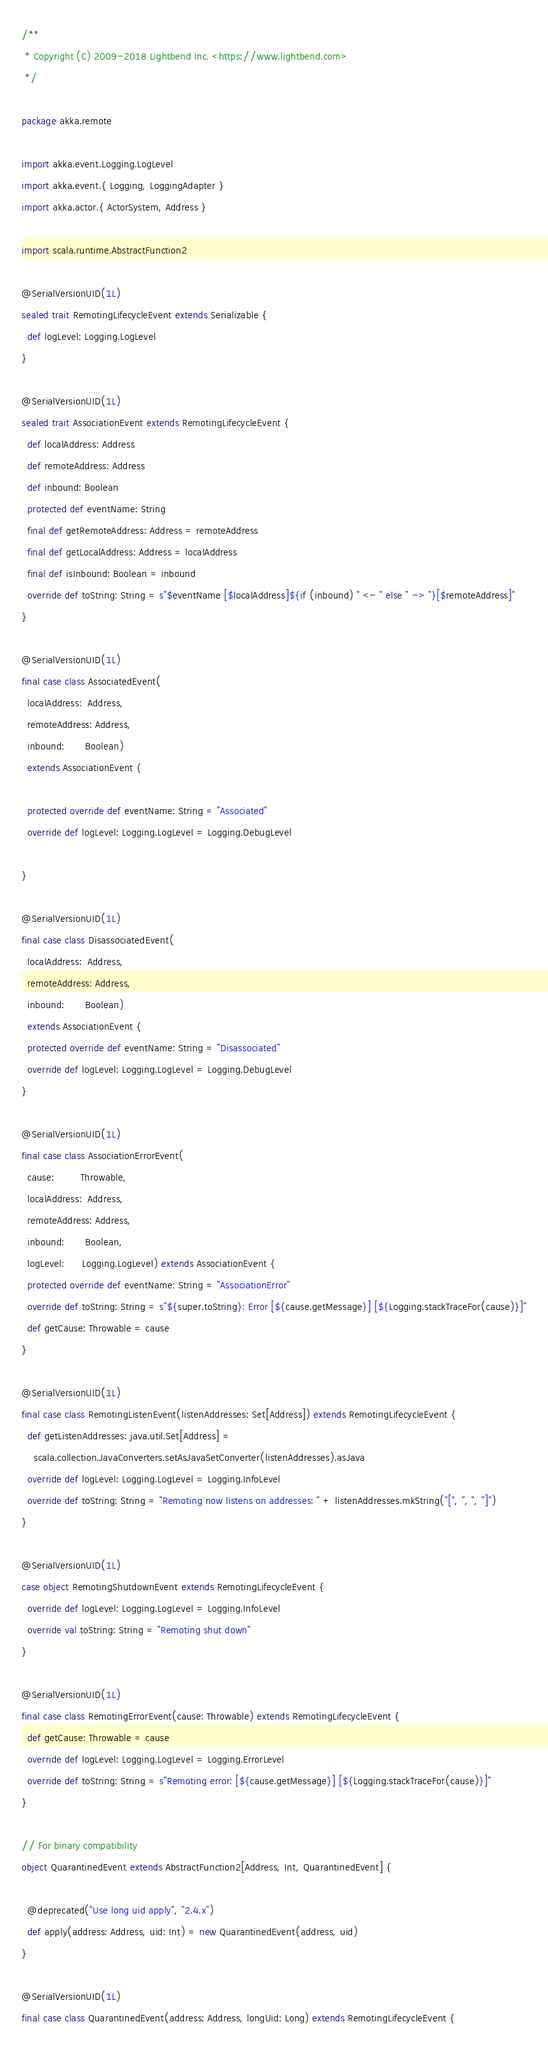<code> <loc_0><loc_0><loc_500><loc_500><_Scala_>/**
 * Copyright (C) 2009-2018 Lightbend Inc. <https://www.lightbend.com>
 */

package akka.remote

import akka.event.Logging.LogLevel
import akka.event.{ Logging, LoggingAdapter }
import akka.actor.{ ActorSystem, Address }

import scala.runtime.AbstractFunction2

@SerialVersionUID(1L)
sealed trait RemotingLifecycleEvent extends Serializable {
  def logLevel: Logging.LogLevel
}

@SerialVersionUID(1L)
sealed trait AssociationEvent extends RemotingLifecycleEvent {
  def localAddress: Address
  def remoteAddress: Address
  def inbound: Boolean
  protected def eventName: String
  final def getRemoteAddress: Address = remoteAddress
  final def getLocalAddress: Address = localAddress
  final def isInbound: Boolean = inbound
  override def toString: String = s"$eventName [$localAddress]${if (inbound) " <- " else " -> "}[$remoteAddress]"
}

@SerialVersionUID(1L)
final case class AssociatedEvent(
  localAddress:  Address,
  remoteAddress: Address,
  inbound:       Boolean)
  extends AssociationEvent {

  protected override def eventName: String = "Associated"
  override def logLevel: Logging.LogLevel = Logging.DebugLevel

}

@SerialVersionUID(1L)
final case class DisassociatedEvent(
  localAddress:  Address,
  remoteAddress: Address,
  inbound:       Boolean)
  extends AssociationEvent {
  protected override def eventName: String = "Disassociated"
  override def logLevel: Logging.LogLevel = Logging.DebugLevel
}

@SerialVersionUID(1L)
final case class AssociationErrorEvent(
  cause:         Throwable,
  localAddress:  Address,
  remoteAddress: Address,
  inbound:       Boolean,
  logLevel:      Logging.LogLevel) extends AssociationEvent {
  protected override def eventName: String = "AssociationError"
  override def toString: String = s"${super.toString}: Error [${cause.getMessage}] [${Logging.stackTraceFor(cause)}]"
  def getCause: Throwable = cause
}

@SerialVersionUID(1L)
final case class RemotingListenEvent(listenAddresses: Set[Address]) extends RemotingLifecycleEvent {
  def getListenAddresses: java.util.Set[Address] =
    scala.collection.JavaConverters.setAsJavaSetConverter(listenAddresses).asJava
  override def logLevel: Logging.LogLevel = Logging.InfoLevel
  override def toString: String = "Remoting now listens on addresses: " + listenAddresses.mkString("[", ", ", "]")
}

@SerialVersionUID(1L)
case object RemotingShutdownEvent extends RemotingLifecycleEvent {
  override def logLevel: Logging.LogLevel = Logging.InfoLevel
  override val toString: String = "Remoting shut down"
}

@SerialVersionUID(1L)
final case class RemotingErrorEvent(cause: Throwable) extends RemotingLifecycleEvent {
  def getCause: Throwable = cause
  override def logLevel: Logging.LogLevel = Logging.ErrorLevel
  override def toString: String = s"Remoting error: [${cause.getMessage}] [${Logging.stackTraceFor(cause)}]"
}

// For binary compatibility
object QuarantinedEvent extends AbstractFunction2[Address, Int, QuarantinedEvent] {

  @deprecated("Use long uid apply", "2.4.x")
  def apply(address: Address, uid: Int) = new QuarantinedEvent(address, uid)
}

@SerialVersionUID(1L)
final case class QuarantinedEvent(address: Address, longUid: Long) extends RemotingLifecycleEvent {
</code> 